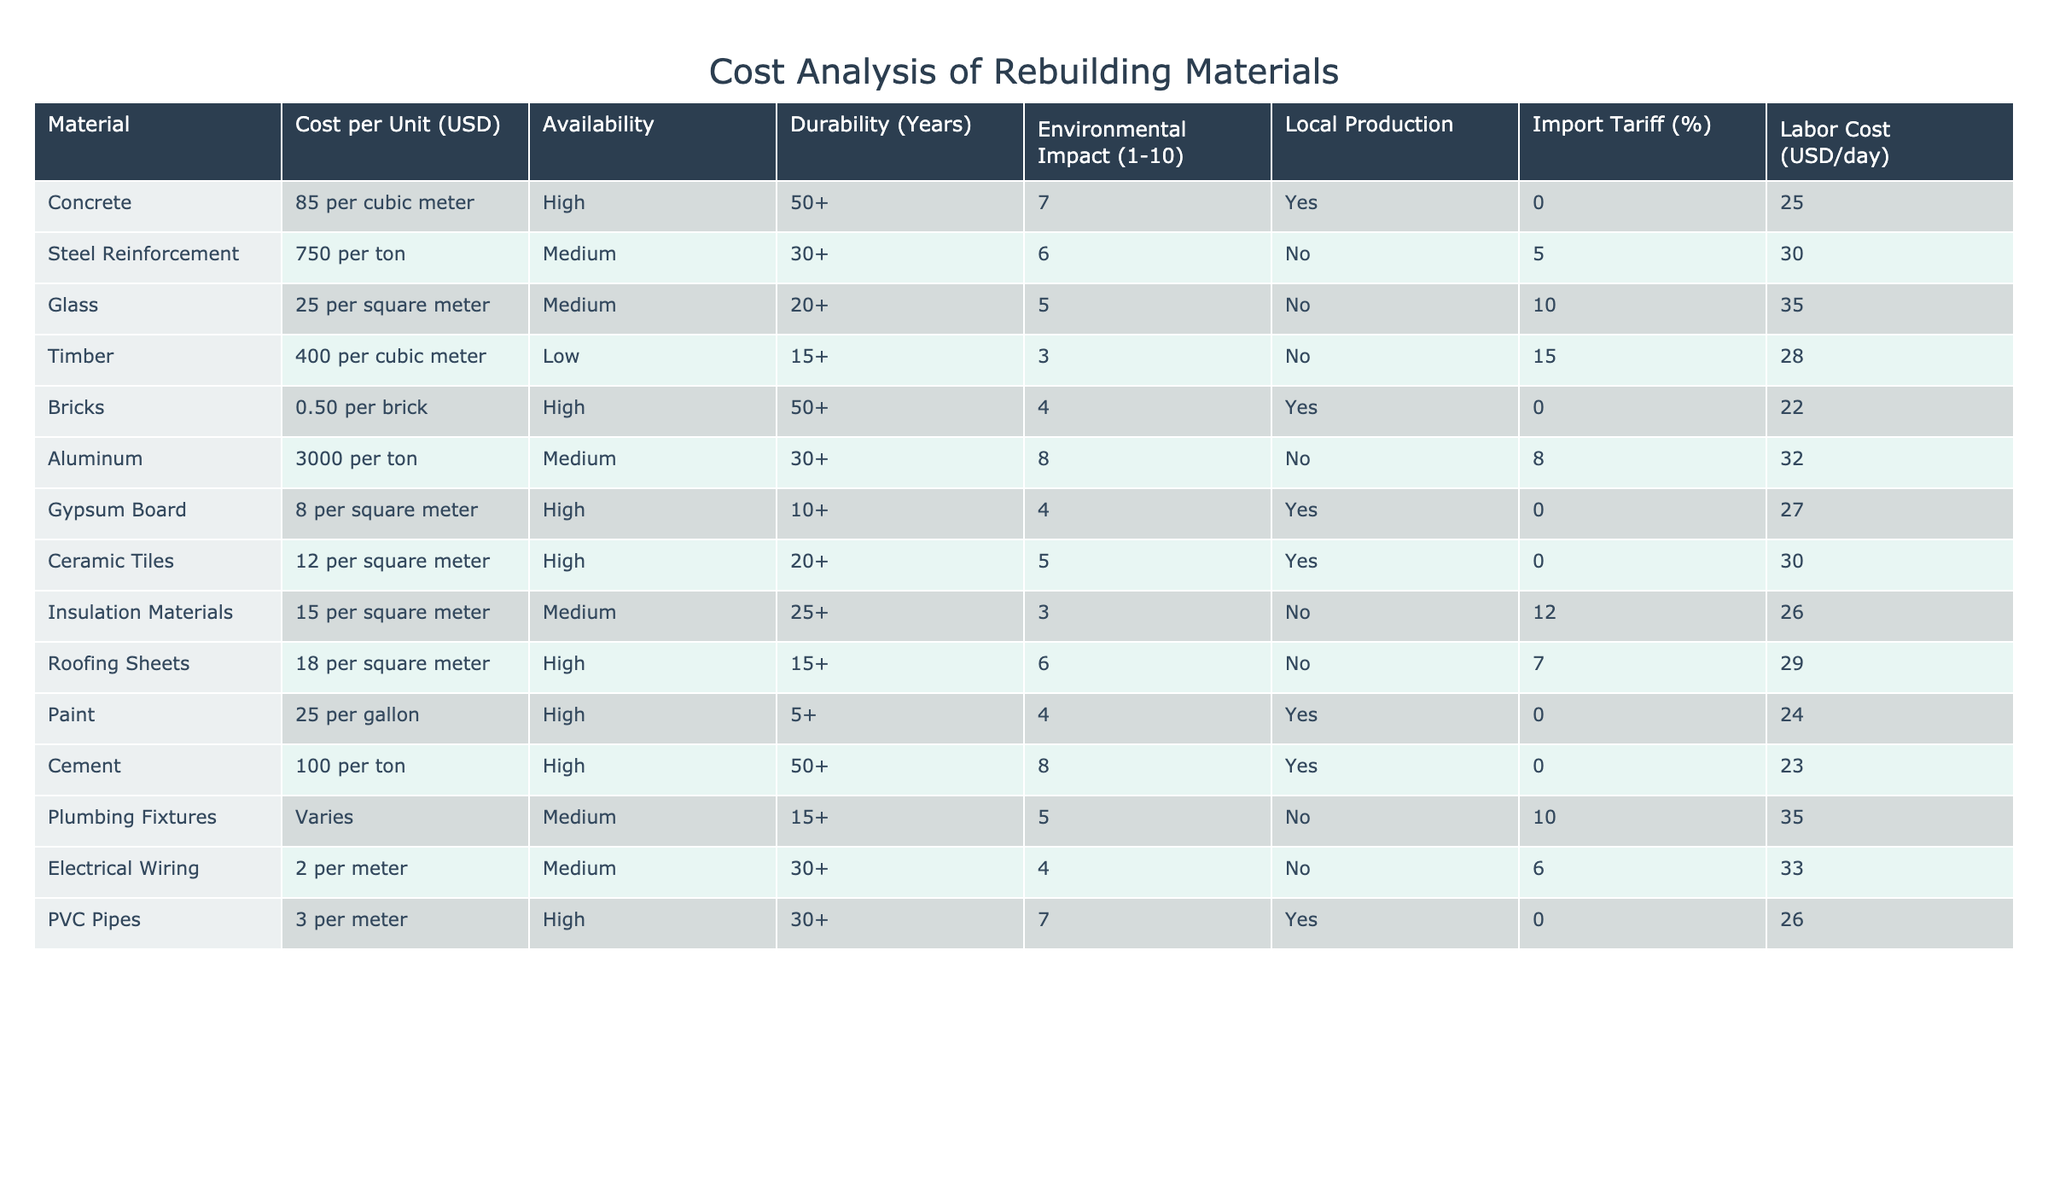What is the cost per unit of concrete? The cost per unit of concrete is specified in the table under the "Cost per Unit (USD)" column, where it reads "85 per cubic meter."
Answer: 85 per cubic meter Is aluminum locally produced? The "Local Production" column indicates whether the material is produced locally, and for aluminum, it is marked as "No."
Answer: No Which material has the highest environmental impact rating? By comparing the "Environmental Impact" ratings across all materials, aluminum has the highest score of 8.
Answer: Aluminum What is the average labor cost of the materials listed? To calculate the average labor cost, sum the labor costs from all materials and then divide by the number of materials. The labor costs are: 25, 30, 35, 28, 22, 32, 27, 30, 26, 24, 23, 35, 33, 26, leading to a total of  546. There are 15 materials, so the average is 546 / 15 = 36.4.
Answer: 36.4 Are there any materials with a durability of 30 years or more? By scanning the "Durability (Years)" column, both concrete and steel reinforcement have durability ratings of 50+ and 30+, respectively, indicating that they meet the criteria.
Answer: Yes How many materials have a medium availability status? The "Availability" column categorizes materials, and the total count of "Medium" ratings is 5 (Steel Reinforcement, Glass, Insulation Materials, Electrical Wiring, Aluminum).
Answer: 5 What is the cost difference between the most and least expensive material? The table shows that aluminum is the most expensive at 3000 per ton and bricks are the least expensive at 0.50 per brick. The cost difference is calculated by converting bricks to per ton for comparison: 0.50 per brick means 500 per ton (assuming 1000 bricks in a ton), so 3000 - 500 = 2500.
Answer: 2500 Which material has the highest import tariff percentage? Looking at the "Import Tariff (%)" column, timber has the highest import tariff at 15%.
Answer: 15% Is insulation material available locally? In the "Local Production" column, insulation materials are indicated as "No," showing they are not produced locally.
Answer: No 